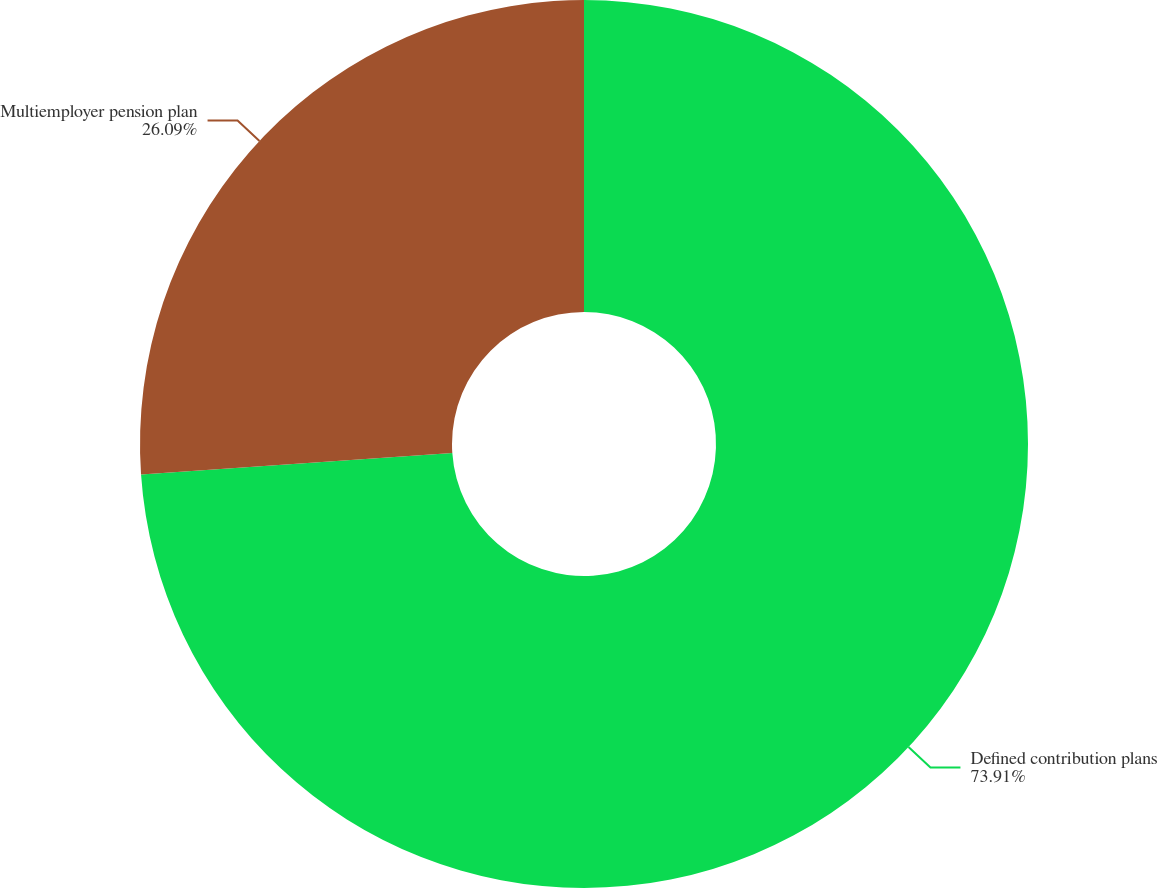Convert chart. <chart><loc_0><loc_0><loc_500><loc_500><pie_chart><fcel>Defined contribution plans<fcel>Multiemployer pension plan<nl><fcel>73.91%<fcel>26.09%<nl></chart> 